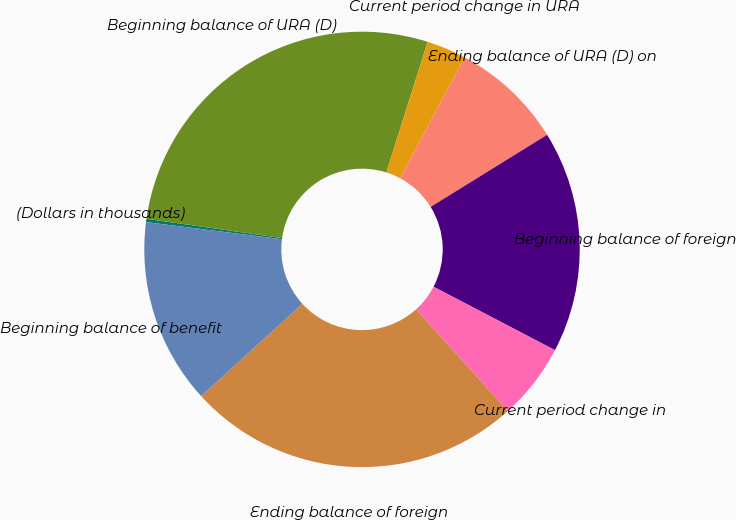Convert chart to OTSL. <chart><loc_0><loc_0><loc_500><loc_500><pie_chart><fcel>(Dollars in thousands)<fcel>Beginning balance of URA (D)<fcel>Current period change in URA<fcel>Ending balance of URA (D) on<fcel>Beginning balance of foreign<fcel>Current period change in<fcel>Ending balance of foreign<fcel>Beginning balance of benefit<nl><fcel>0.24%<fcel>27.63%<fcel>2.94%<fcel>8.36%<fcel>16.48%<fcel>5.65%<fcel>24.92%<fcel>13.77%<nl></chart> 